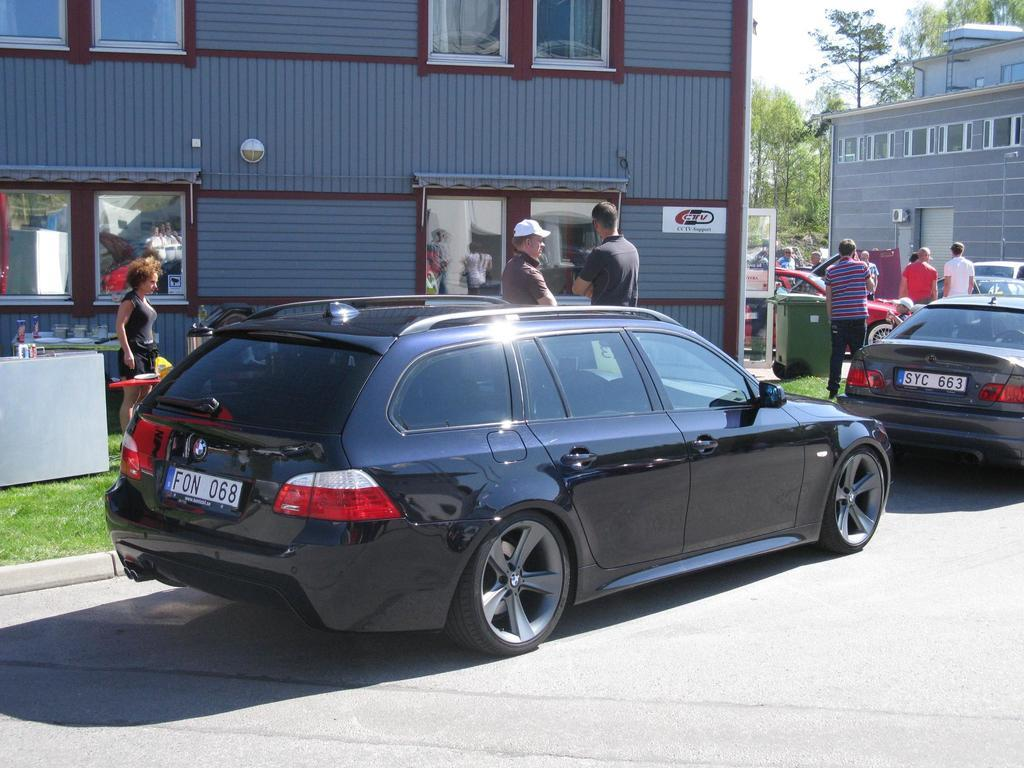<image>
Relay a brief, clear account of the picture shown. A black vehicle that is parked has the license plate F0N 068. 